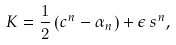Convert formula to latex. <formula><loc_0><loc_0><loc_500><loc_500>K = \frac { 1 } { 2 } \left ( c ^ { n } - \alpha _ { n } \right ) + \epsilon \, s ^ { n } ,</formula> 